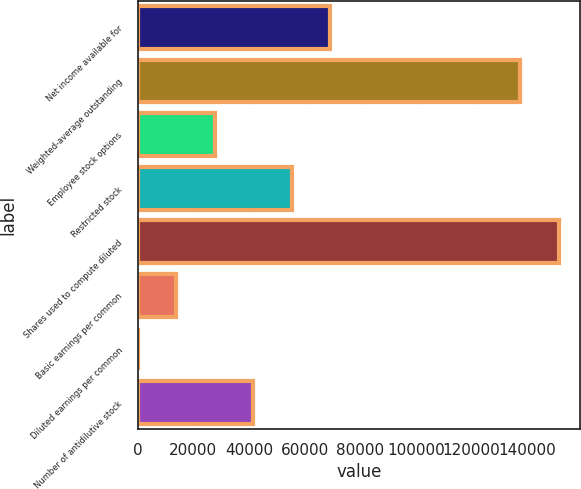Convert chart to OTSL. <chart><loc_0><loc_0><loc_500><loc_500><bar_chart><fcel>Net income available for<fcel>Weighted-average outstanding<fcel>Employee stock options<fcel>Restricted stock<fcel>Shares used to compute diluted<fcel>Basic earnings per common<fcel>Diluted earnings per common<fcel>Number of antidilutive stock<nl><fcel>69207.6<fcel>137486<fcel>27690.3<fcel>55368.5<fcel>151325<fcel>13851.2<fcel>12.16<fcel>41529.4<nl></chart> 